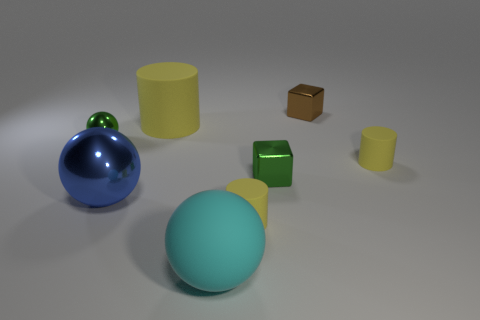There is a block that is to the right of the green block behind the big cyan sphere; is there a yellow cylinder that is behind it?
Provide a short and direct response. No. What number of small objects are metallic things or yellow things?
Your response must be concise. 5. There is a matte cylinder that is the same size as the blue metal ball; what color is it?
Your answer should be very brief. Yellow. There is a blue thing; what number of yellow things are left of it?
Your answer should be compact. 0. Are there any balls that have the same material as the large yellow object?
Provide a succinct answer. Yes. There is a small shiny object that is the same color as the tiny metallic ball; what shape is it?
Make the answer very short. Cube. What color is the matte cylinder that is in front of the green shiny block?
Your answer should be very brief. Yellow. Are there the same number of big cyan objects in front of the cyan sphere and brown metal cubes that are in front of the big metal ball?
Give a very brief answer. Yes. What material is the tiny green object on the right side of the ball that is in front of the large metallic sphere?
Make the answer very short. Metal. How many things are large balls or cubes in front of the green ball?
Your answer should be compact. 3. 